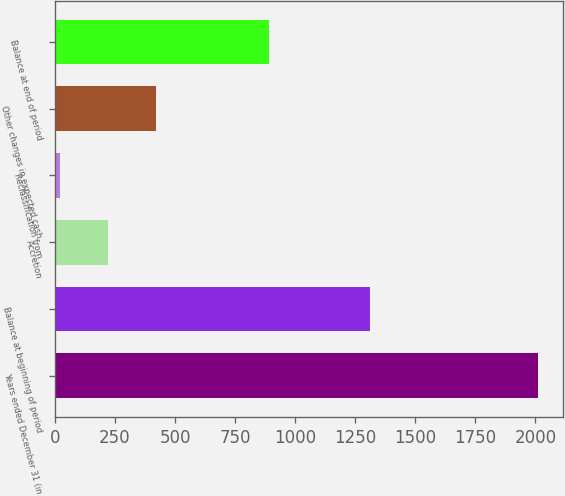Convert chart to OTSL. <chart><loc_0><loc_0><loc_500><loc_500><bar_chart><fcel>Years ended December 31 (in<fcel>Balance at beginning of period<fcel>Accretion<fcel>Reclassification from<fcel>Other changes in expected cash<fcel>Balance at end of period<nl><fcel>2012<fcel>1310.4<fcel>221.63<fcel>22.7<fcel>420.56<fcel>890.2<nl></chart> 